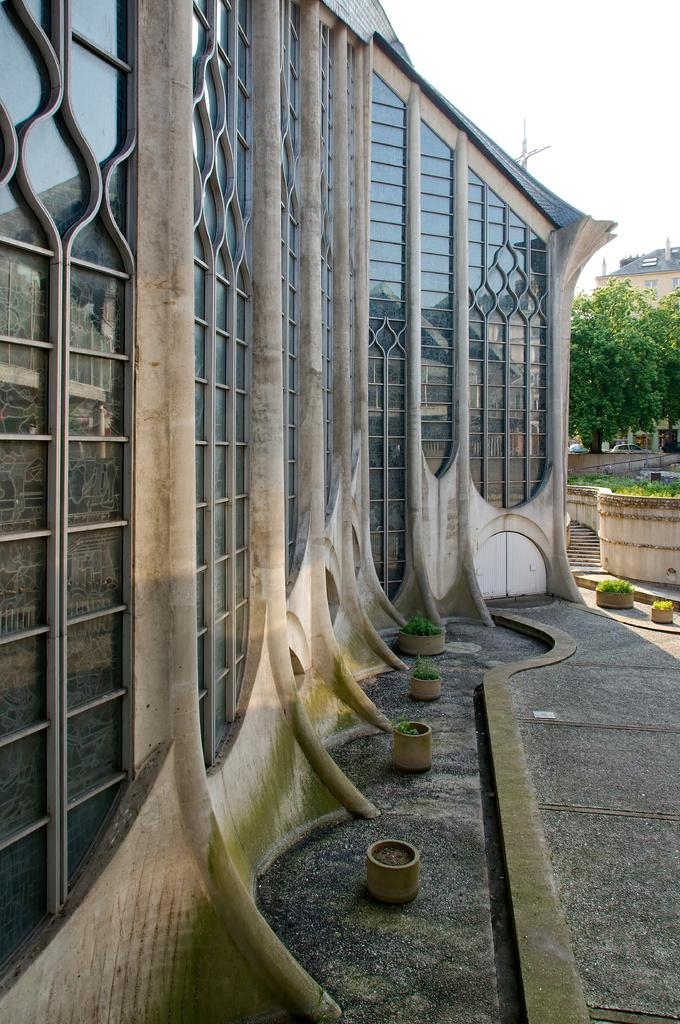What type of structure is present in the image? The image contains a building. What features can be seen on the building? There are windows and grills on the building. What is located next to the building? There is a tree and plants next to the building. What color is the hair on the roof of the building in the image? There is no hair present on the roof of the building in the image. 